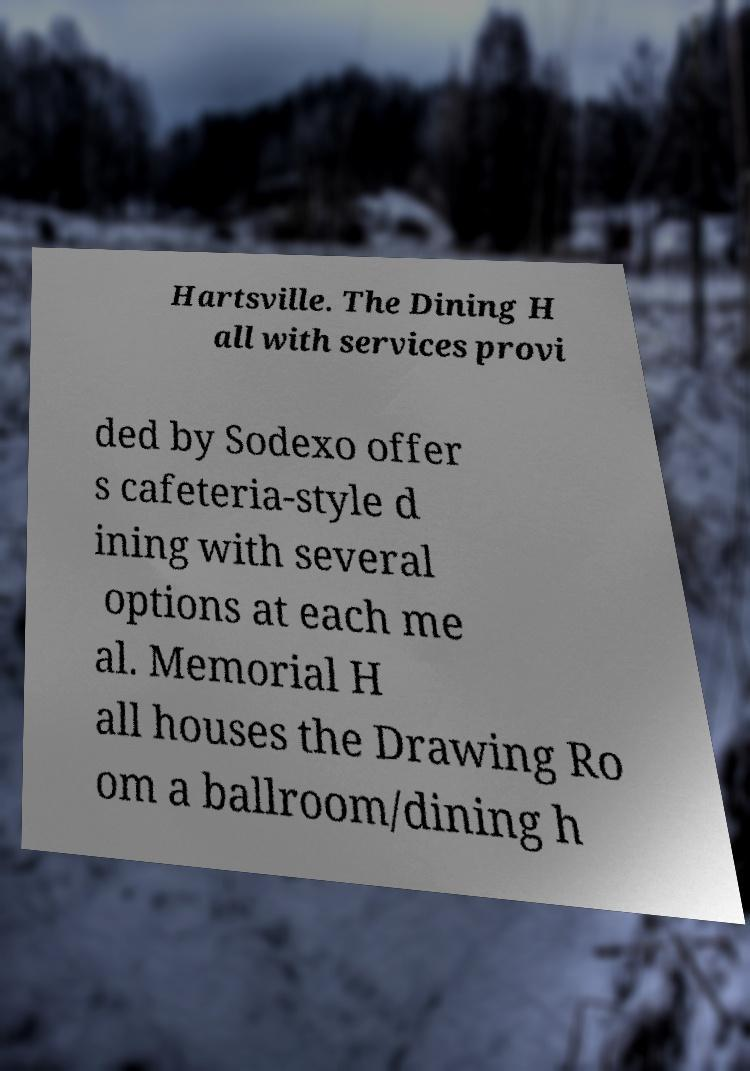Could you assist in decoding the text presented in this image and type it out clearly? Hartsville. The Dining H all with services provi ded by Sodexo offer s cafeteria-style d ining with several options at each me al. Memorial H all houses the Drawing Ro om a ballroom/dining h 